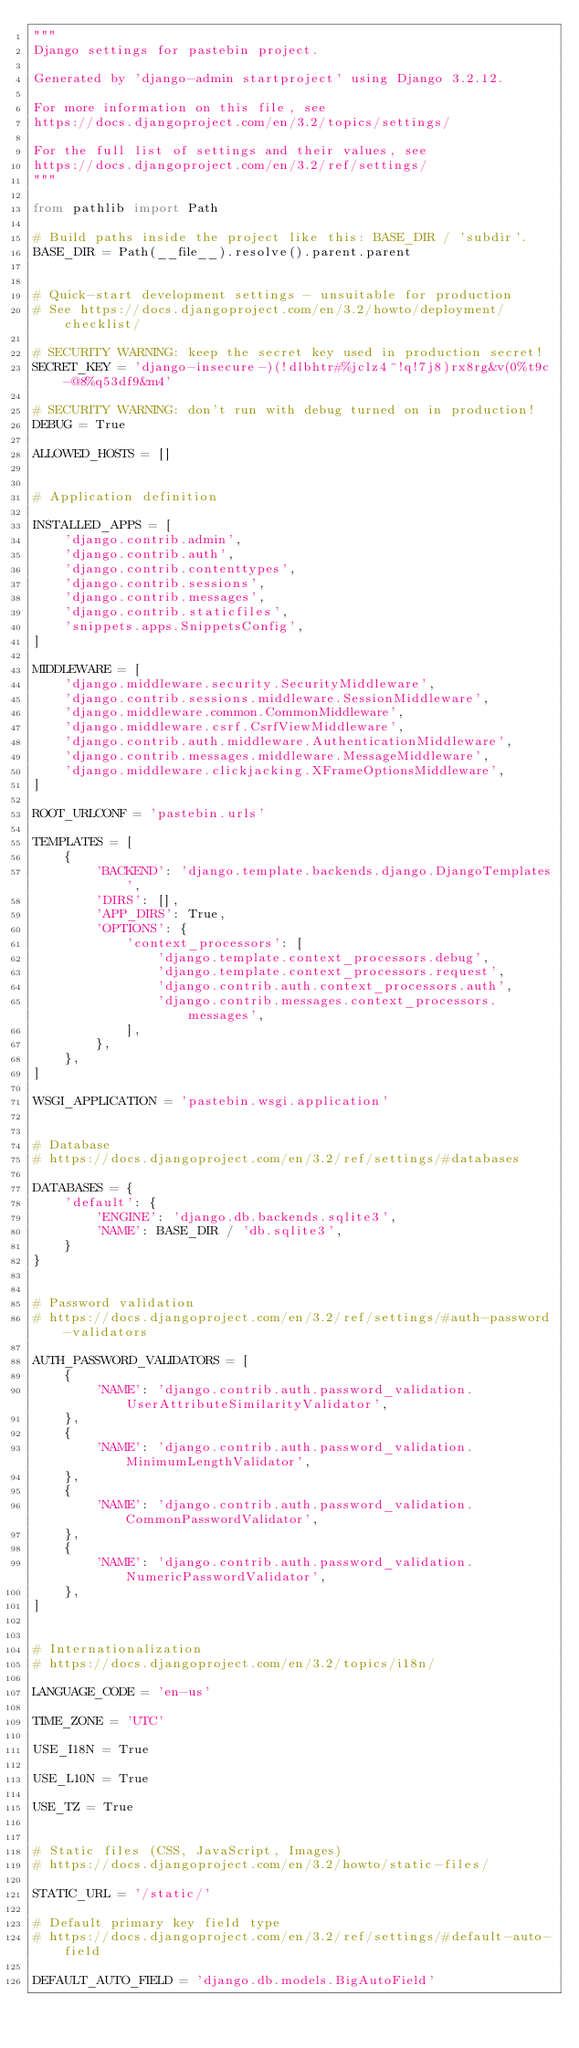Convert code to text. <code><loc_0><loc_0><loc_500><loc_500><_Python_>"""
Django settings for pastebin project.

Generated by 'django-admin startproject' using Django 3.2.12.

For more information on this file, see
https://docs.djangoproject.com/en/3.2/topics/settings/

For the full list of settings and their values, see
https://docs.djangoproject.com/en/3.2/ref/settings/
"""

from pathlib import Path

# Build paths inside the project like this: BASE_DIR / 'subdir'.
BASE_DIR = Path(__file__).resolve().parent.parent


# Quick-start development settings - unsuitable for production
# See https://docs.djangoproject.com/en/3.2/howto/deployment/checklist/

# SECURITY WARNING: keep the secret key used in production secret!
SECRET_KEY = 'django-insecure-)(!dlbhtr#%jclz4^!q!7j8)rx8rg&v(0%t9c-@8%q53df9&m4'

# SECURITY WARNING: don't run with debug turned on in production!
DEBUG = True

ALLOWED_HOSTS = []


# Application definition

INSTALLED_APPS = [
    'django.contrib.admin',
    'django.contrib.auth',
    'django.contrib.contenttypes',
    'django.contrib.sessions',
    'django.contrib.messages',
    'django.contrib.staticfiles',
    'snippets.apps.SnippetsConfig',
]

MIDDLEWARE = [
    'django.middleware.security.SecurityMiddleware',
    'django.contrib.sessions.middleware.SessionMiddleware',
    'django.middleware.common.CommonMiddleware',
    'django.middleware.csrf.CsrfViewMiddleware',
    'django.contrib.auth.middleware.AuthenticationMiddleware',
    'django.contrib.messages.middleware.MessageMiddleware',
    'django.middleware.clickjacking.XFrameOptionsMiddleware',
]

ROOT_URLCONF = 'pastebin.urls'

TEMPLATES = [
    {
        'BACKEND': 'django.template.backends.django.DjangoTemplates',
        'DIRS': [],
        'APP_DIRS': True,
        'OPTIONS': {
            'context_processors': [
                'django.template.context_processors.debug',
                'django.template.context_processors.request',
                'django.contrib.auth.context_processors.auth',
                'django.contrib.messages.context_processors.messages',
            ],
        },
    },
]

WSGI_APPLICATION = 'pastebin.wsgi.application'


# Database
# https://docs.djangoproject.com/en/3.2/ref/settings/#databases

DATABASES = {
    'default': {
        'ENGINE': 'django.db.backends.sqlite3',
        'NAME': BASE_DIR / 'db.sqlite3',
    }
}


# Password validation
# https://docs.djangoproject.com/en/3.2/ref/settings/#auth-password-validators

AUTH_PASSWORD_VALIDATORS = [
    {
        'NAME': 'django.contrib.auth.password_validation.UserAttributeSimilarityValidator',
    },
    {
        'NAME': 'django.contrib.auth.password_validation.MinimumLengthValidator',
    },
    {
        'NAME': 'django.contrib.auth.password_validation.CommonPasswordValidator',
    },
    {
        'NAME': 'django.contrib.auth.password_validation.NumericPasswordValidator',
    },
]


# Internationalization
# https://docs.djangoproject.com/en/3.2/topics/i18n/

LANGUAGE_CODE = 'en-us'

TIME_ZONE = 'UTC'

USE_I18N = True

USE_L10N = True

USE_TZ = True


# Static files (CSS, JavaScript, Images)
# https://docs.djangoproject.com/en/3.2/howto/static-files/

STATIC_URL = '/static/'

# Default primary key field type
# https://docs.djangoproject.com/en/3.2/ref/settings/#default-auto-field

DEFAULT_AUTO_FIELD = 'django.db.models.BigAutoField'
</code> 